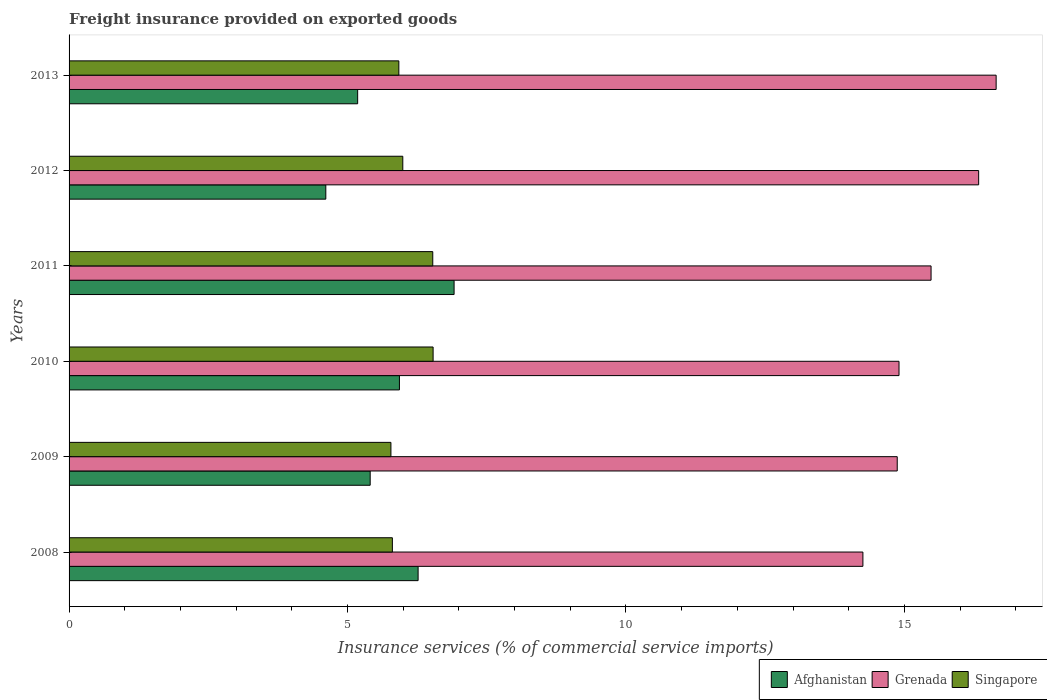How many different coloured bars are there?
Offer a terse response. 3. How many groups of bars are there?
Your response must be concise. 6. Are the number of bars on each tick of the Y-axis equal?
Give a very brief answer. Yes. How many bars are there on the 6th tick from the bottom?
Your response must be concise. 3. What is the freight insurance provided on exported goods in Grenada in 2011?
Your answer should be compact. 15.48. Across all years, what is the maximum freight insurance provided on exported goods in Singapore?
Offer a very short reply. 6.54. Across all years, what is the minimum freight insurance provided on exported goods in Grenada?
Your response must be concise. 14.25. In which year was the freight insurance provided on exported goods in Singapore minimum?
Give a very brief answer. 2009. What is the total freight insurance provided on exported goods in Afghanistan in the graph?
Your answer should be very brief. 34.31. What is the difference between the freight insurance provided on exported goods in Afghanistan in 2010 and that in 2011?
Your answer should be very brief. -0.98. What is the difference between the freight insurance provided on exported goods in Grenada in 2013 and the freight insurance provided on exported goods in Afghanistan in 2012?
Ensure brevity in your answer.  12.04. What is the average freight insurance provided on exported goods in Grenada per year?
Your answer should be compact. 15.41. In the year 2013, what is the difference between the freight insurance provided on exported goods in Singapore and freight insurance provided on exported goods in Grenada?
Your answer should be very brief. -10.73. In how many years, is the freight insurance provided on exported goods in Singapore greater than 16 %?
Make the answer very short. 0. What is the ratio of the freight insurance provided on exported goods in Grenada in 2011 to that in 2012?
Make the answer very short. 0.95. Is the freight insurance provided on exported goods in Singapore in 2012 less than that in 2013?
Ensure brevity in your answer.  No. What is the difference between the highest and the second highest freight insurance provided on exported goods in Grenada?
Provide a succinct answer. 0.31. What is the difference between the highest and the lowest freight insurance provided on exported goods in Grenada?
Ensure brevity in your answer.  2.39. Is the sum of the freight insurance provided on exported goods in Afghanistan in 2010 and 2013 greater than the maximum freight insurance provided on exported goods in Singapore across all years?
Keep it short and to the point. Yes. What does the 1st bar from the top in 2013 represents?
Keep it short and to the point. Singapore. What does the 2nd bar from the bottom in 2010 represents?
Keep it short and to the point. Grenada. Is it the case that in every year, the sum of the freight insurance provided on exported goods in Singapore and freight insurance provided on exported goods in Afghanistan is greater than the freight insurance provided on exported goods in Grenada?
Offer a very short reply. No. Are all the bars in the graph horizontal?
Make the answer very short. Yes. How many years are there in the graph?
Keep it short and to the point. 6. What is the difference between two consecutive major ticks on the X-axis?
Your response must be concise. 5. Does the graph contain grids?
Your answer should be very brief. No. Where does the legend appear in the graph?
Provide a succinct answer. Bottom right. How many legend labels are there?
Offer a very short reply. 3. What is the title of the graph?
Your answer should be compact. Freight insurance provided on exported goods. What is the label or title of the X-axis?
Offer a terse response. Insurance services (% of commercial service imports). What is the label or title of the Y-axis?
Provide a short and direct response. Years. What is the Insurance services (% of commercial service imports) in Afghanistan in 2008?
Offer a very short reply. 6.27. What is the Insurance services (% of commercial service imports) of Grenada in 2008?
Offer a terse response. 14.25. What is the Insurance services (% of commercial service imports) in Singapore in 2008?
Provide a succinct answer. 5.81. What is the Insurance services (% of commercial service imports) of Afghanistan in 2009?
Provide a short and direct response. 5.41. What is the Insurance services (% of commercial service imports) of Grenada in 2009?
Give a very brief answer. 14.87. What is the Insurance services (% of commercial service imports) of Singapore in 2009?
Provide a short and direct response. 5.78. What is the Insurance services (% of commercial service imports) of Afghanistan in 2010?
Offer a terse response. 5.93. What is the Insurance services (% of commercial service imports) of Grenada in 2010?
Provide a short and direct response. 14.9. What is the Insurance services (% of commercial service imports) in Singapore in 2010?
Provide a succinct answer. 6.54. What is the Insurance services (% of commercial service imports) in Afghanistan in 2011?
Provide a short and direct response. 6.91. What is the Insurance services (% of commercial service imports) in Grenada in 2011?
Give a very brief answer. 15.48. What is the Insurance services (% of commercial service imports) in Singapore in 2011?
Provide a succinct answer. 6.53. What is the Insurance services (% of commercial service imports) of Afghanistan in 2012?
Your answer should be very brief. 4.61. What is the Insurance services (% of commercial service imports) in Grenada in 2012?
Your response must be concise. 16.33. What is the Insurance services (% of commercial service imports) of Singapore in 2012?
Offer a very short reply. 5.99. What is the Insurance services (% of commercial service imports) of Afghanistan in 2013?
Make the answer very short. 5.18. What is the Insurance services (% of commercial service imports) in Grenada in 2013?
Your answer should be compact. 16.65. What is the Insurance services (% of commercial service imports) of Singapore in 2013?
Ensure brevity in your answer.  5.92. Across all years, what is the maximum Insurance services (% of commercial service imports) in Afghanistan?
Keep it short and to the point. 6.91. Across all years, what is the maximum Insurance services (% of commercial service imports) of Grenada?
Ensure brevity in your answer.  16.65. Across all years, what is the maximum Insurance services (% of commercial service imports) in Singapore?
Offer a terse response. 6.54. Across all years, what is the minimum Insurance services (% of commercial service imports) in Afghanistan?
Provide a short and direct response. 4.61. Across all years, what is the minimum Insurance services (% of commercial service imports) of Grenada?
Your response must be concise. 14.25. Across all years, what is the minimum Insurance services (% of commercial service imports) of Singapore?
Keep it short and to the point. 5.78. What is the total Insurance services (% of commercial service imports) in Afghanistan in the graph?
Keep it short and to the point. 34.31. What is the total Insurance services (% of commercial service imports) of Grenada in the graph?
Provide a short and direct response. 92.49. What is the total Insurance services (% of commercial service imports) in Singapore in the graph?
Your answer should be very brief. 36.57. What is the difference between the Insurance services (% of commercial service imports) in Afghanistan in 2008 and that in 2009?
Keep it short and to the point. 0.86. What is the difference between the Insurance services (% of commercial service imports) of Grenada in 2008 and that in 2009?
Provide a succinct answer. -0.62. What is the difference between the Insurance services (% of commercial service imports) of Singapore in 2008 and that in 2009?
Your answer should be compact. 0.03. What is the difference between the Insurance services (% of commercial service imports) of Afghanistan in 2008 and that in 2010?
Offer a terse response. 0.34. What is the difference between the Insurance services (% of commercial service imports) of Grenada in 2008 and that in 2010?
Your answer should be compact. -0.65. What is the difference between the Insurance services (% of commercial service imports) of Singapore in 2008 and that in 2010?
Provide a short and direct response. -0.73. What is the difference between the Insurance services (% of commercial service imports) of Afghanistan in 2008 and that in 2011?
Give a very brief answer. -0.65. What is the difference between the Insurance services (% of commercial service imports) in Grenada in 2008 and that in 2011?
Offer a very short reply. -1.22. What is the difference between the Insurance services (% of commercial service imports) in Singapore in 2008 and that in 2011?
Provide a short and direct response. -0.73. What is the difference between the Insurance services (% of commercial service imports) in Afghanistan in 2008 and that in 2012?
Keep it short and to the point. 1.66. What is the difference between the Insurance services (% of commercial service imports) of Grenada in 2008 and that in 2012?
Keep it short and to the point. -2.08. What is the difference between the Insurance services (% of commercial service imports) in Singapore in 2008 and that in 2012?
Your answer should be compact. -0.19. What is the difference between the Insurance services (% of commercial service imports) of Afghanistan in 2008 and that in 2013?
Give a very brief answer. 1.09. What is the difference between the Insurance services (% of commercial service imports) in Grenada in 2008 and that in 2013?
Provide a short and direct response. -2.39. What is the difference between the Insurance services (% of commercial service imports) in Singapore in 2008 and that in 2013?
Ensure brevity in your answer.  -0.12. What is the difference between the Insurance services (% of commercial service imports) in Afghanistan in 2009 and that in 2010?
Provide a short and direct response. -0.53. What is the difference between the Insurance services (% of commercial service imports) in Grenada in 2009 and that in 2010?
Offer a very short reply. -0.03. What is the difference between the Insurance services (% of commercial service imports) of Singapore in 2009 and that in 2010?
Your answer should be compact. -0.76. What is the difference between the Insurance services (% of commercial service imports) in Afghanistan in 2009 and that in 2011?
Keep it short and to the point. -1.51. What is the difference between the Insurance services (% of commercial service imports) of Grenada in 2009 and that in 2011?
Your answer should be compact. -0.61. What is the difference between the Insurance services (% of commercial service imports) in Singapore in 2009 and that in 2011?
Offer a terse response. -0.75. What is the difference between the Insurance services (% of commercial service imports) in Afghanistan in 2009 and that in 2012?
Your response must be concise. 0.8. What is the difference between the Insurance services (% of commercial service imports) of Grenada in 2009 and that in 2012?
Your response must be concise. -1.46. What is the difference between the Insurance services (% of commercial service imports) of Singapore in 2009 and that in 2012?
Give a very brief answer. -0.21. What is the difference between the Insurance services (% of commercial service imports) of Afghanistan in 2009 and that in 2013?
Offer a terse response. 0.23. What is the difference between the Insurance services (% of commercial service imports) in Grenada in 2009 and that in 2013?
Offer a very short reply. -1.78. What is the difference between the Insurance services (% of commercial service imports) in Singapore in 2009 and that in 2013?
Keep it short and to the point. -0.14. What is the difference between the Insurance services (% of commercial service imports) of Afghanistan in 2010 and that in 2011?
Keep it short and to the point. -0.98. What is the difference between the Insurance services (% of commercial service imports) in Grenada in 2010 and that in 2011?
Your response must be concise. -0.58. What is the difference between the Insurance services (% of commercial service imports) in Singapore in 2010 and that in 2011?
Offer a terse response. 0.01. What is the difference between the Insurance services (% of commercial service imports) in Afghanistan in 2010 and that in 2012?
Your response must be concise. 1.32. What is the difference between the Insurance services (% of commercial service imports) in Grenada in 2010 and that in 2012?
Make the answer very short. -1.43. What is the difference between the Insurance services (% of commercial service imports) in Singapore in 2010 and that in 2012?
Your answer should be compact. 0.54. What is the difference between the Insurance services (% of commercial service imports) of Afghanistan in 2010 and that in 2013?
Your answer should be very brief. 0.75. What is the difference between the Insurance services (% of commercial service imports) of Grenada in 2010 and that in 2013?
Offer a very short reply. -1.74. What is the difference between the Insurance services (% of commercial service imports) of Singapore in 2010 and that in 2013?
Offer a very short reply. 0.62. What is the difference between the Insurance services (% of commercial service imports) of Afghanistan in 2011 and that in 2012?
Offer a very short reply. 2.3. What is the difference between the Insurance services (% of commercial service imports) in Grenada in 2011 and that in 2012?
Provide a succinct answer. -0.85. What is the difference between the Insurance services (% of commercial service imports) of Singapore in 2011 and that in 2012?
Offer a very short reply. 0.54. What is the difference between the Insurance services (% of commercial service imports) in Afghanistan in 2011 and that in 2013?
Offer a very short reply. 1.73. What is the difference between the Insurance services (% of commercial service imports) in Grenada in 2011 and that in 2013?
Your answer should be very brief. -1.17. What is the difference between the Insurance services (% of commercial service imports) of Singapore in 2011 and that in 2013?
Keep it short and to the point. 0.61. What is the difference between the Insurance services (% of commercial service imports) in Afghanistan in 2012 and that in 2013?
Give a very brief answer. -0.57. What is the difference between the Insurance services (% of commercial service imports) of Grenada in 2012 and that in 2013?
Provide a succinct answer. -0.31. What is the difference between the Insurance services (% of commercial service imports) in Singapore in 2012 and that in 2013?
Provide a short and direct response. 0.07. What is the difference between the Insurance services (% of commercial service imports) of Afghanistan in 2008 and the Insurance services (% of commercial service imports) of Grenada in 2009?
Ensure brevity in your answer.  -8.6. What is the difference between the Insurance services (% of commercial service imports) of Afghanistan in 2008 and the Insurance services (% of commercial service imports) of Singapore in 2009?
Ensure brevity in your answer.  0.49. What is the difference between the Insurance services (% of commercial service imports) in Grenada in 2008 and the Insurance services (% of commercial service imports) in Singapore in 2009?
Offer a terse response. 8.48. What is the difference between the Insurance services (% of commercial service imports) in Afghanistan in 2008 and the Insurance services (% of commercial service imports) in Grenada in 2010?
Provide a short and direct response. -8.64. What is the difference between the Insurance services (% of commercial service imports) of Afghanistan in 2008 and the Insurance services (% of commercial service imports) of Singapore in 2010?
Your response must be concise. -0.27. What is the difference between the Insurance services (% of commercial service imports) of Grenada in 2008 and the Insurance services (% of commercial service imports) of Singapore in 2010?
Ensure brevity in your answer.  7.72. What is the difference between the Insurance services (% of commercial service imports) of Afghanistan in 2008 and the Insurance services (% of commercial service imports) of Grenada in 2011?
Ensure brevity in your answer.  -9.21. What is the difference between the Insurance services (% of commercial service imports) in Afghanistan in 2008 and the Insurance services (% of commercial service imports) in Singapore in 2011?
Make the answer very short. -0.26. What is the difference between the Insurance services (% of commercial service imports) in Grenada in 2008 and the Insurance services (% of commercial service imports) in Singapore in 2011?
Make the answer very short. 7.72. What is the difference between the Insurance services (% of commercial service imports) in Afghanistan in 2008 and the Insurance services (% of commercial service imports) in Grenada in 2012?
Offer a terse response. -10.07. What is the difference between the Insurance services (% of commercial service imports) in Afghanistan in 2008 and the Insurance services (% of commercial service imports) in Singapore in 2012?
Keep it short and to the point. 0.27. What is the difference between the Insurance services (% of commercial service imports) of Grenada in 2008 and the Insurance services (% of commercial service imports) of Singapore in 2012?
Offer a terse response. 8.26. What is the difference between the Insurance services (% of commercial service imports) in Afghanistan in 2008 and the Insurance services (% of commercial service imports) in Grenada in 2013?
Your answer should be compact. -10.38. What is the difference between the Insurance services (% of commercial service imports) in Afghanistan in 2008 and the Insurance services (% of commercial service imports) in Singapore in 2013?
Give a very brief answer. 0.35. What is the difference between the Insurance services (% of commercial service imports) in Grenada in 2008 and the Insurance services (% of commercial service imports) in Singapore in 2013?
Your answer should be compact. 8.33. What is the difference between the Insurance services (% of commercial service imports) in Afghanistan in 2009 and the Insurance services (% of commercial service imports) in Grenada in 2010?
Offer a very short reply. -9.5. What is the difference between the Insurance services (% of commercial service imports) of Afghanistan in 2009 and the Insurance services (% of commercial service imports) of Singapore in 2010?
Give a very brief answer. -1.13. What is the difference between the Insurance services (% of commercial service imports) of Grenada in 2009 and the Insurance services (% of commercial service imports) of Singapore in 2010?
Give a very brief answer. 8.33. What is the difference between the Insurance services (% of commercial service imports) of Afghanistan in 2009 and the Insurance services (% of commercial service imports) of Grenada in 2011?
Your response must be concise. -10.07. What is the difference between the Insurance services (% of commercial service imports) in Afghanistan in 2009 and the Insurance services (% of commercial service imports) in Singapore in 2011?
Provide a short and direct response. -1.12. What is the difference between the Insurance services (% of commercial service imports) in Grenada in 2009 and the Insurance services (% of commercial service imports) in Singapore in 2011?
Your response must be concise. 8.34. What is the difference between the Insurance services (% of commercial service imports) of Afghanistan in 2009 and the Insurance services (% of commercial service imports) of Grenada in 2012?
Ensure brevity in your answer.  -10.93. What is the difference between the Insurance services (% of commercial service imports) of Afghanistan in 2009 and the Insurance services (% of commercial service imports) of Singapore in 2012?
Keep it short and to the point. -0.59. What is the difference between the Insurance services (% of commercial service imports) of Grenada in 2009 and the Insurance services (% of commercial service imports) of Singapore in 2012?
Give a very brief answer. 8.88. What is the difference between the Insurance services (% of commercial service imports) of Afghanistan in 2009 and the Insurance services (% of commercial service imports) of Grenada in 2013?
Ensure brevity in your answer.  -11.24. What is the difference between the Insurance services (% of commercial service imports) in Afghanistan in 2009 and the Insurance services (% of commercial service imports) in Singapore in 2013?
Keep it short and to the point. -0.51. What is the difference between the Insurance services (% of commercial service imports) in Grenada in 2009 and the Insurance services (% of commercial service imports) in Singapore in 2013?
Keep it short and to the point. 8.95. What is the difference between the Insurance services (% of commercial service imports) in Afghanistan in 2010 and the Insurance services (% of commercial service imports) in Grenada in 2011?
Your response must be concise. -9.55. What is the difference between the Insurance services (% of commercial service imports) of Afghanistan in 2010 and the Insurance services (% of commercial service imports) of Singapore in 2011?
Offer a very short reply. -0.6. What is the difference between the Insurance services (% of commercial service imports) of Grenada in 2010 and the Insurance services (% of commercial service imports) of Singapore in 2011?
Ensure brevity in your answer.  8.37. What is the difference between the Insurance services (% of commercial service imports) of Afghanistan in 2010 and the Insurance services (% of commercial service imports) of Grenada in 2012?
Your answer should be compact. -10.4. What is the difference between the Insurance services (% of commercial service imports) in Afghanistan in 2010 and the Insurance services (% of commercial service imports) in Singapore in 2012?
Ensure brevity in your answer.  -0.06. What is the difference between the Insurance services (% of commercial service imports) of Grenada in 2010 and the Insurance services (% of commercial service imports) of Singapore in 2012?
Your response must be concise. 8.91. What is the difference between the Insurance services (% of commercial service imports) in Afghanistan in 2010 and the Insurance services (% of commercial service imports) in Grenada in 2013?
Provide a short and direct response. -10.71. What is the difference between the Insurance services (% of commercial service imports) in Afghanistan in 2010 and the Insurance services (% of commercial service imports) in Singapore in 2013?
Offer a very short reply. 0.01. What is the difference between the Insurance services (% of commercial service imports) in Grenada in 2010 and the Insurance services (% of commercial service imports) in Singapore in 2013?
Provide a succinct answer. 8.98. What is the difference between the Insurance services (% of commercial service imports) in Afghanistan in 2011 and the Insurance services (% of commercial service imports) in Grenada in 2012?
Keep it short and to the point. -9.42. What is the difference between the Insurance services (% of commercial service imports) of Afghanistan in 2011 and the Insurance services (% of commercial service imports) of Singapore in 2012?
Provide a short and direct response. 0.92. What is the difference between the Insurance services (% of commercial service imports) of Grenada in 2011 and the Insurance services (% of commercial service imports) of Singapore in 2012?
Offer a terse response. 9.49. What is the difference between the Insurance services (% of commercial service imports) in Afghanistan in 2011 and the Insurance services (% of commercial service imports) in Grenada in 2013?
Keep it short and to the point. -9.73. What is the difference between the Insurance services (% of commercial service imports) of Afghanistan in 2011 and the Insurance services (% of commercial service imports) of Singapore in 2013?
Your answer should be very brief. 0.99. What is the difference between the Insurance services (% of commercial service imports) of Grenada in 2011 and the Insurance services (% of commercial service imports) of Singapore in 2013?
Give a very brief answer. 9.56. What is the difference between the Insurance services (% of commercial service imports) in Afghanistan in 2012 and the Insurance services (% of commercial service imports) in Grenada in 2013?
Keep it short and to the point. -12.04. What is the difference between the Insurance services (% of commercial service imports) in Afghanistan in 2012 and the Insurance services (% of commercial service imports) in Singapore in 2013?
Give a very brief answer. -1.31. What is the difference between the Insurance services (% of commercial service imports) of Grenada in 2012 and the Insurance services (% of commercial service imports) of Singapore in 2013?
Ensure brevity in your answer.  10.41. What is the average Insurance services (% of commercial service imports) of Afghanistan per year?
Ensure brevity in your answer.  5.72. What is the average Insurance services (% of commercial service imports) of Grenada per year?
Your response must be concise. 15.41. What is the average Insurance services (% of commercial service imports) in Singapore per year?
Provide a succinct answer. 6.09. In the year 2008, what is the difference between the Insurance services (% of commercial service imports) in Afghanistan and Insurance services (% of commercial service imports) in Grenada?
Give a very brief answer. -7.99. In the year 2008, what is the difference between the Insurance services (% of commercial service imports) in Afghanistan and Insurance services (% of commercial service imports) in Singapore?
Your answer should be very brief. 0.46. In the year 2008, what is the difference between the Insurance services (% of commercial service imports) in Grenada and Insurance services (% of commercial service imports) in Singapore?
Give a very brief answer. 8.45. In the year 2009, what is the difference between the Insurance services (% of commercial service imports) in Afghanistan and Insurance services (% of commercial service imports) in Grenada?
Offer a very short reply. -9.46. In the year 2009, what is the difference between the Insurance services (% of commercial service imports) of Afghanistan and Insurance services (% of commercial service imports) of Singapore?
Your answer should be compact. -0.37. In the year 2009, what is the difference between the Insurance services (% of commercial service imports) of Grenada and Insurance services (% of commercial service imports) of Singapore?
Give a very brief answer. 9.09. In the year 2010, what is the difference between the Insurance services (% of commercial service imports) of Afghanistan and Insurance services (% of commercial service imports) of Grenada?
Provide a short and direct response. -8.97. In the year 2010, what is the difference between the Insurance services (% of commercial service imports) of Afghanistan and Insurance services (% of commercial service imports) of Singapore?
Your response must be concise. -0.6. In the year 2010, what is the difference between the Insurance services (% of commercial service imports) of Grenada and Insurance services (% of commercial service imports) of Singapore?
Your answer should be very brief. 8.37. In the year 2011, what is the difference between the Insurance services (% of commercial service imports) of Afghanistan and Insurance services (% of commercial service imports) of Grenada?
Make the answer very short. -8.56. In the year 2011, what is the difference between the Insurance services (% of commercial service imports) in Afghanistan and Insurance services (% of commercial service imports) in Singapore?
Ensure brevity in your answer.  0.38. In the year 2011, what is the difference between the Insurance services (% of commercial service imports) in Grenada and Insurance services (% of commercial service imports) in Singapore?
Provide a short and direct response. 8.95. In the year 2012, what is the difference between the Insurance services (% of commercial service imports) of Afghanistan and Insurance services (% of commercial service imports) of Grenada?
Provide a short and direct response. -11.72. In the year 2012, what is the difference between the Insurance services (% of commercial service imports) in Afghanistan and Insurance services (% of commercial service imports) in Singapore?
Your answer should be compact. -1.38. In the year 2012, what is the difference between the Insurance services (% of commercial service imports) of Grenada and Insurance services (% of commercial service imports) of Singapore?
Offer a terse response. 10.34. In the year 2013, what is the difference between the Insurance services (% of commercial service imports) of Afghanistan and Insurance services (% of commercial service imports) of Grenada?
Provide a short and direct response. -11.47. In the year 2013, what is the difference between the Insurance services (% of commercial service imports) in Afghanistan and Insurance services (% of commercial service imports) in Singapore?
Give a very brief answer. -0.74. In the year 2013, what is the difference between the Insurance services (% of commercial service imports) in Grenada and Insurance services (% of commercial service imports) in Singapore?
Your answer should be very brief. 10.73. What is the ratio of the Insurance services (% of commercial service imports) in Afghanistan in 2008 to that in 2009?
Your answer should be very brief. 1.16. What is the ratio of the Insurance services (% of commercial service imports) of Grenada in 2008 to that in 2009?
Keep it short and to the point. 0.96. What is the ratio of the Insurance services (% of commercial service imports) of Afghanistan in 2008 to that in 2010?
Your answer should be compact. 1.06. What is the ratio of the Insurance services (% of commercial service imports) of Grenada in 2008 to that in 2010?
Make the answer very short. 0.96. What is the ratio of the Insurance services (% of commercial service imports) in Singapore in 2008 to that in 2010?
Provide a succinct answer. 0.89. What is the ratio of the Insurance services (% of commercial service imports) in Afghanistan in 2008 to that in 2011?
Offer a very short reply. 0.91. What is the ratio of the Insurance services (% of commercial service imports) of Grenada in 2008 to that in 2011?
Offer a very short reply. 0.92. What is the ratio of the Insurance services (% of commercial service imports) of Singapore in 2008 to that in 2011?
Ensure brevity in your answer.  0.89. What is the ratio of the Insurance services (% of commercial service imports) of Afghanistan in 2008 to that in 2012?
Offer a very short reply. 1.36. What is the ratio of the Insurance services (% of commercial service imports) in Grenada in 2008 to that in 2012?
Offer a very short reply. 0.87. What is the ratio of the Insurance services (% of commercial service imports) in Singapore in 2008 to that in 2012?
Provide a succinct answer. 0.97. What is the ratio of the Insurance services (% of commercial service imports) in Afghanistan in 2008 to that in 2013?
Your answer should be compact. 1.21. What is the ratio of the Insurance services (% of commercial service imports) in Grenada in 2008 to that in 2013?
Make the answer very short. 0.86. What is the ratio of the Insurance services (% of commercial service imports) of Singapore in 2008 to that in 2013?
Give a very brief answer. 0.98. What is the ratio of the Insurance services (% of commercial service imports) of Afghanistan in 2009 to that in 2010?
Keep it short and to the point. 0.91. What is the ratio of the Insurance services (% of commercial service imports) in Singapore in 2009 to that in 2010?
Provide a short and direct response. 0.88. What is the ratio of the Insurance services (% of commercial service imports) in Afghanistan in 2009 to that in 2011?
Offer a terse response. 0.78. What is the ratio of the Insurance services (% of commercial service imports) of Grenada in 2009 to that in 2011?
Give a very brief answer. 0.96. What is the ratio of the Insurance services (% of commercial service imports) of Singapore in 2009 to that in 2011?
Provide a succinct answer. 0.89. What is the ratio of the Insurance services (% of commercial service imports) in Afghanistan in 2009 to that in 2012?
Your answer should be very brief. 1.17. What is the ratio of the Insurance services (% of commercial service imports) of Grenada in 2009 to that in 2012?
Ensure brevity in your answer.  0.91. What is the ratio of the Insurance services (% of commercial service imports) in Singapore in 2009 to that in 2012?
Make the answer very short. 0.96. What is the ratio of the Insurance services (% of commercial service imports) of Afghanistan in 2009 to that in 2013?
Your answer should be compact. 1.04. What is the ratio of the Insurance services (% of commercial service imports) of Grenada in 2009 to that in 2013?
Offer a very short reply. 0.89. What is the ratio of the Insurance services (% of commercial service imports) of Singapore in 2009 to that in 2013?
Give a very brief answer. 0.98. What is the ratio of the Insurance services (% of commercial service imports) of Afghanistan in 2010 to that in 2011?
Your answer should be very brief. 0.86. What is the ratio of the Insurance services (% of commercial service imports) in Grenada in 2010 to that in 2011?
Ensure brevity in your answer.  0.96. What is the ratio of the Insurance services (% of commercial service imports) in Singapore in 2010 to that in 2011?
Ensure brevity in your answer.  1. What is the ratio of the Insurance services (% of commercial service imports) in Afghanistan in 2010 to that in 2012?
Give a very brief answer. 1.29. What is the ratio of the Insurance services (% of commercial service imports) in Grenada in 2010 to that in 2012?
Your response must be concise. 0.91. What is the ratio of the Insurance services (% of commercial service imports) in Singapore in 2010 to that in 2012?
Your answer should be compact. 1.09. What is the ratio of the Insurance services (% of commercial service imports) of Afghanistan in 2010 to that in 2013?
Provide a short and direct response. 1.14. What is the ratio of the Insurance services (% of commercial service imports) in Grenada in 2010 to that in 2013?
Provide a short and direct response. 0.9. What is the ratio of the Insurance services (% of commercial service imports) of Singapore in 2010 to that in 2013?
Ensure brevity in your answer.  1.1. What is the ratio of the Insurance services (% of commercial service imports) of Afghanistan in 2011 to that in 2012?
Provide a succinct answer. 1.5. What is the ratio of the Insurance services (% of commercial service imports) of Grenada in 2011 to that in 2012?
Give a very brief answer. 0.95. What is the ratio of the Insurance services (% of commercial service imports) of Singapore in 2011 to that in 2012?
Ensure brevity in your answer.  1.09. What is the ratio of the Insurance services (% of commercial service imports) in Afghanistan in 2011 to that in 2013?
Your answer should be very brief. 1.33. What is the ratio of the Insurance services (% of commercial service imports) of Grenada in 2011 to that in 2013?
Ensure brevity in your answer.  0.93. What is the ratio of the Insurance services (% of commercial service imports) in Singapore in 2011 to that in 2013?
Provide a succinct answer. 1.1. What is the ratio of the Insurance services (% of commercial service imports) of Afghanistan in 2012 to that in 2013?
Your response must be concise. 0.89. What is the ratio of the Insurance services (% of commercial service imports) of Grenada in 2012 to that in 2013?
Make the answer very short. 0.98. What is the ratio of the Insurance services (% of commercial service imports) in Singapore in 2012 to that in 2013?
Provide a succinct answer. 1.01. What is the difference between the highest and the second highest Insurance services (% of commercial service imports) of Afghanistan?
Offer a very short reply. 0.65. What is the difference between the highest and the second highest Insurance services (% of commercial service imports) in Grenada?
Provide a succinct answer. 0.31. What is the difference between the highest and the second highest Insurance services (% of commercial service imports) in Singapore?
Give a very brief answer. 0.01. What is the difference between the highest and the lowest Insurance services (% of commercial service imports) of Afghanistan?
Make the answer very short. 2.3. What is the difference between the highest and the lowest Insurance services (% of commercial service imports) of Grenada?
Your answer should be compact. 2.39. What is the difference between the highest and the lowest Insurance services (% of commercial service imports) in Singapore?
Your answer should be very brief. 0.76. 